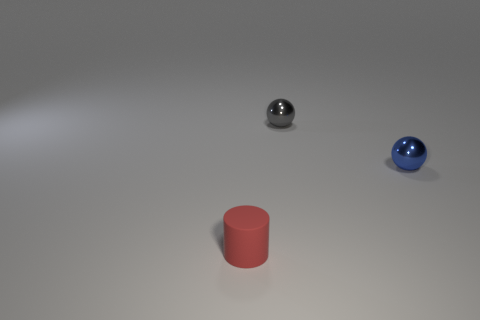Add 1 small red rubber things. How many objects exist? 4 Subtract all spheres. How many objects are left? 1 Subtract 1 cylinders. How many cylinders are left? 0 Subtract all red balls. Subtract all cyan cylinders. How many balls are left? 2 Subtract 0 brown cylinders. How many objects are left? 3 Subtract all purple cylinders. How many red balls are left? 0 Subtract all tiny red rubber things. Subtract all blue things. How many objects are left? 1 Add 1 blue metallic balls. How many blue metallic balls are left? 2 Add 1 small metal spheres. How many small metal spheres exist? 3 